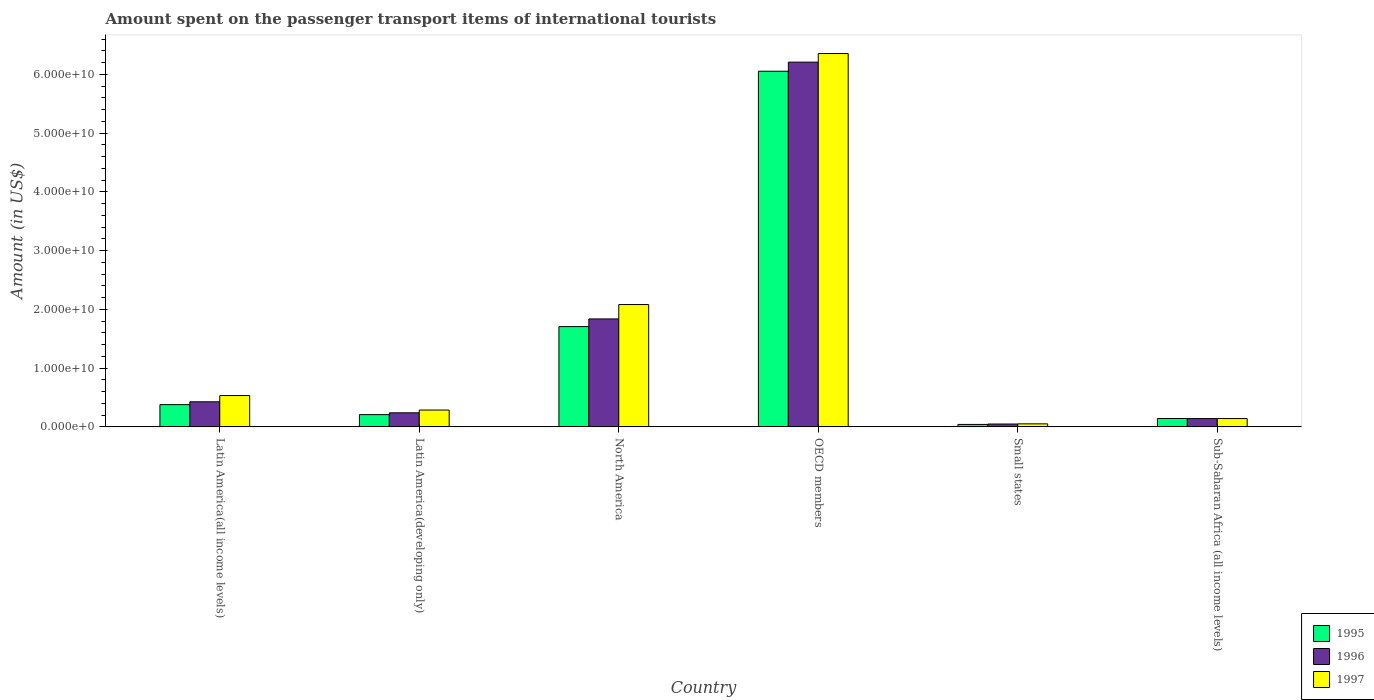How many different coloured bars are there?
Give a very brief answer. 3. How many groups of bars are there?
Keep it short and to the point. 6. Are the number of bars on each tick of the X-axis equal?
Your response must be concise. Yes. How many bars are there on the 3rd tick from the right?
Give a very brief answer. 3. What is the label of the 4th group of bars from the left?
Provide a short and direct response. OECD members. What is the amount spent on the passenger transport items of international tourists in 1997 in Small states?
Make the answer very short. 5.15e+08. Across all countries, what is the maximum amount spent on the passenger transport items of international tourists in 1996?
Your response must be concise. 6.21e+1. Across all countries, what is the minimum amount spent on the passenger transport items of international tourists in 1995?
Keep it short and to the point. 4.15e+08. In which country was the amount spent on the passenger transport items of international tourists in 1995 maximum?
Offer a terse response. OECD members. In which country was the amount spent on the passenger transport items of international tourists in 1995 minimum?
Ensure brevity in your answer.  Small states. What is the total amount spent on the passenger transport items of international tourists in 1995 in the graph?
Offer a terse response. 8.53e+1. What is the difference between the amount spent on the passenger transport items of international tourists in 1995 in Latin America(developing only) and that in Small states?
Your answer should be very brief. 1.67e+09. What is the difference between the amount spent on the passenger transport items of international tourists in 1996 in Latin America(all income levels) and the amount spent on the passenger transport items of international tourists in 1997 in Sub-Saharan Africa (all income levels)?
Your response must be concise. 2.85e+09. What is the average amount spent on the passenger transport items of international tourists in 1995 per country?
Provide a short and direct response. 1.42e+1. What is the difference between the amount spent on the passenger transport items of international tourists of/in 1997 and amount spent on the passenger transport items of international tourists of/in 1995 in Sub-Saharan Africa (all income levels)?
Your response must be concise. -7.08e+06. In how many countries, is the amount spent on the passenger transport items of international tourists in 1996 greater than 64000000000 US$?
Make the answer very short. 0. What is the ratio of the amount spent on the passenger transport items of international tourists in 1996 in North America to that in OECD members?
Your answer should be compact. 0.3. What is the difference between the highest and the second highest amount spent on the passenger transport items of international tourists in 1995?
Your answer should be very brief. -5.68e+1. What is the difference between the highest and the lowest amount spent on the passenger transport items of international tourists in 1997?
Provide a succinct answer. 6.30e+1. Is the sum of the amount spent on the passenger transport items of international tourists in 1997 in Latin America(all income levels) and North America greater than the maximum amount spent on the passenger transport items of international tourists in 1996 across all countries?
Provide a succinct answer. No. Are the values on the major ticks of Y-axis written in scientific E-notation?
Provide a short and direct response. Yes. Does the graph contain any zero values?
Your answer should be compact. No. Does the graph contain grids?
Your answer should be very brief. No. How are the legend labels stacked?
Your response must be concise. Vertical. What is the title of the graph?
Ensure brevity in your answer.  Amount spent on the passenger transport items of international tourists. Does "2000" appear as one of the legend labels in the graph?
Provide a short and direct response. No. What is the label or title of the Y-axis?
Your answer should be very brief. Amount (in US$). What is the Amount (in US$) in 1995 in Latin America(all income levels)?
Make the answer very short. 3.79e+09. What is the Amount (in US$) in 1996 in Latin America(all income levels)?
Your answer should be very brief. 4.27e+09. What is the Amount (in US$) in 1997 in Latin America(all income levels)?
Ensure brevity in your answer.  5.33e+09. What is the Amount (in US$) in 1995 in Latin America(developing only)?
Ensure brevity in your answer.  2.08e+09. What is the Amount (in US$) of 1996 in Latin America(developing only)?
Offer a very short reply. 2.39e+09. What is the Amount (in US$) in 1997 in Latin America(developing only)?
Offer a terse response. 2.87e+09. What is the Amount (in US$) in 1995 in North America?
Offer a very short reply. 1.71e+1. What is the Amount (in US$) of 1996 in North America?
Provide a succinct answer. 1.84e+1. What is the Amount (in US$) in 1997 in North America?
Your answer should be very brief. 2.08e+1. What is the Amount (in US$) of 1995 in OECD members?
Make the answer very short. 6.05e+1. What is the Amount (in US$) of 1996 in OECD members?
Keep it short and to the point. 6.21e+1. What is the Amount (in US$) of 1997 in OECD members?
Offer a very short reply. 6.35e+1. What is the Amount (in US$) of 1995 in Small states?
Offer a very short reply. 4.15e+08. What is the Amount (in US$) of 1996 in Small states?
Your answer should be compact. 4.85e+08. What is the Amount (in US$) in 1997 in Small states?
Give a very brief answer. 5.15e+08. What is the Amount (in US$) in 1995 in Sub-Saharan Africa (all income levels)?
Provide a short and direct response. 1.42e+09. What is the Amount (in US$) in 1996 in Sub-Saharan Africa (all income levels)?
Ensure brevity in your answer.  1.41e+09. What is the Amount (in US$) of 1997 in Sub-Saharan Africa (all income levels)?
Your answer should be compact. 1.42e+09. Across all countries, what is the maximum Amount (in US$) in 1995?
Your response must be concise. 6.05e+1. Across all countries, what is the maximum Amount (in US$) of 1996?
Offer a very short reply. 6.21e+1. Across all countries, what is the maximum Amount (in US$) in 1997?
Offer a terse response. 6.35e+1. Across all countries, what is the minimum Amount (in US$) in 1995?
Your response must be concise. 4.15e+08. Across all countries, what is the minimum Amount (in US$) in 1996?
Make the answer very short. 4.85e+08. Across all countries, what is the minimum Amount (in US$) of 1997?
Give a very brief answer. 5.15e+08. What is the total Amount (in US$) in 1995 in the graph?
Ensure brevity in your answer.  8.53e+1. What is the total Amount (in US$) in 1996 in the graph?
Your response must be concise. 8.90e+1. What is the total Amount (in US$) of 1997 in the graph?
Give a very brief answer. 9.45e+1. What is the difference between the Amount (in US$) of 1995 in Latin America(all income levels) and that in Latin America(developing only)?
Make the answer very short. 1.70e+09. What is the difference between the Amount (in US$) of 1996 in Latin America(all income levels) and that in Latin America(developing only)?
Provide a short and direct response. 1.88e+09. What is the difference between the Amount (in US$) of 1997 in Latin America(all income levels) and that in Latin America(developing only)?
Your response must be concise. 2.47e+09. What is the difference between the Amount (in US$) in 1995 in Latin America(all income levels) and that in North America?
Ensure brevity in your answer.  -1.33e+1. What is the difference between the Amount (in US$) of 1996 in Latin America(all income levels) and that in North America?
Keep it short and to the point. -1.41e+1. What is the difference between the Amount (in US$) in 1997 in Latin America(all income levels) and that in North America?
Provide a short and direct response. -1.55e+1. What is the difference between the Amount (in US$) in 1995 in Latin America(all income levels) and that in OECD members?
Ensure brevity in your answer.  -5.68e+1. What is the difference between the Amount (in US$) in 1996 in Latin America(all income levels) and that in OECD members?
Ensure brevity in your answer.  -5.78e+1. What is the difference between the Amount (in US$) of 1997 in Latin America(all income levels) and that in OECD members?
Make the answer very short. -5.82e+1. What is the difference between the Amount (in US$) of 1995 in Latin America(all income levels) and that in Small states?
Keep it short and to the point. 3.37e+09. What is the difference between the Amount (in US$) of 1996 in Latin America(all income levels) and that in Small states?
Provide a short and direct response. 3.78e+09. What is the difference between the Amount (in US$) of 1997 in Latin America(all income levels) and that in Small states?
Provide a succinct answer. 4.82e+09. What is the difference between the Amount (in US$) in 1995 in Latin America(all income levels) and that in Sub-Saharan Africa (all income levels)?
Ensure brevity in your answer.  2.36e+09. What is the difference between the Amount (in US$) of 1996 in Latin America(all income levels) and that in Sub-Saharan Africa (all income levels)?
Your answer should be very brief. 2.86e+09. What is the difference between the Amount (in US$) of 1997 in Latin America(all income levels) and that in Sub-Saharan Africa (all income levels)?
Keep it short and to the point. 3.92e+09. What is the difference between the Amount (in US$) of 1995 in Latin America(developing only) and that in North America?
Provide a succinct answer. -1.50e+1. What is the difference between the Amount (in US$) of 1996 in Latin America(developing only) and that in North America?
Offer a terse response. -1.60e+1. What is the difference between the Amount (in US$) of 1997 in Latin America(developing only) and that in North America?
Your answer should be compact. -1.80e+1. What is the difference between the Amount (in US$) in 1995 in Latin America(developing only) and that in OECD members?
Make the answer very short. -5.85e+1. What is the difference between the Amount (in US$) in 1996 in Latin America(developing only) and that in OECD members?
Offer a very short reply. -5.97e+1. What is the difference between the Amount (in US$) of 1997 in Latin America(developing only) and that in OECD members?
Keep it short and to the point. -6.07e+1. What is the difference between the Amount (in US$) in 1995 in Latin America(developing only) and that in Small states?
Give a very brief answer. 1.67e+09. What is the difference between the Amount (in US$) in 1996 in Latin America(developing only) and that in Small states?
Your response must be concise. 1.91e+09. What is the difference between the Amount (in US$) of 1997 in Latin America(developing only) and that in Small states?
Provide a succinct answer. 2.35e+09. What is the difference between the Amount (in US$) in 1995 in Latin America(developing only) and that in Sub-Saharan Africa (all income levels)?
Ensure brevity in your answer.  6.61e+08. What is the difference between the Amount (in US$) of 1996 in Latin America(developing only) and that in Sub-Saharan Africa (all income levels)?
Your response must be concise. 9.78e+08. What is the difference between the Amount (in US$) of 1997 in Latin America(developing only) and that in Sub-Saharan Africa (all income levels)?
Provide a succinct answer. 1.45e+09. What is the difference between the Amount (in US$) in 1995 in North America and that in OECD members?
Your answer should be compact. -4.35e+1. What is the difference between the Amount (in US$) of 1996 in North America and that in OECD members?
Ensure brevity in your answer.  -4.37e+1. What is the difference between the Amount (in US$) in 1997 in North America and that in OECD members?
Give a very brief answer. -4.27e+1. What is the difference between the Amount (in US$) of 1995 in North America and that in Small states?
Offer a very short reply. 1.67e+1. What is the difference between the Amount (in US$) in 1996 in North America and that in Small states?
Make the answer very short. 1.79e+1. What is the difference between the Amount (in US$) of 1997 in North America and that in Small states?
Your response must be concise. 2.03e+1. What is the difference between the Amount (in US$) in 1995 in North America and that in Sub-Saharan Africa (all income levels)?
Ensure brevity in your answer.  1.56e+1. What is the difference between the Amount (in US$) in 1996 in North America and that in Sub-Saharan Africa (all income levels)?
Your answer should be very brief. 1.70e+1. What is the difference between the Amount (in US$) of 1997 in North America and that in Sub-Saharan Africa (all income levels)?
Provide a short and direct response. 1.94e+1. What is the difference between the Amount (in US$) of 1995 in OECD members and that in Small states?
Make the answer very short. 6.01e+1. What is the difference between the Amount (in US$) in 1996 in OECD members and that in Small states?
Provide a succinct answer. 6.16e+1. What is the difference between the Amount (in US$) in 1997 in OECD members and that in Small states?
Make the answer very short. 6.30e+1. What is the difference between the Amount (in US$) of 1995 in OECD members and that in Sub-Saharan Africa (all income levels)?
Offer a very short reply. 5.91e+1. What is the difference between the Amount (in US$) of 1996 in OECD members and that in Sub-Saharan Africa (all income levels)?
Your answer should be very brief. 6.07e+1. What is the difference between the Amount (in US$) in 1997 in OECD members and that in Sub-Saharan Africa (all income levels)?
Offer a very short reply. 6.21e+1. What is the difference between the Amount (in US$) of 1995 in Small states and that in Sub-Saharan Africa (all income levels)?
Ensure brevity in your answer.  -1.01e+09. What is the difference between the Amount (in US$) of 1996 in Small states and that in Sub-Saharan Africa (all income levels)?
Ensure brevity in your answer.  -9.28e+08. What is the difference between the Amount (in US$) of 1997 in Small states and that in Sub-Saharan Africa (all income levels)?
Offer a very short reply. -9.01e+08. What is the difference between the Amount (in US$) of 1995 in Latin America(all income levels) and the Amount (in US$) of 1996 in Latin America(developing only)?
Your response must be concise. 1.39e+09. What is the difference between the Amount (in US$) in 1995 in Latin America(all income levels) and the Amount (in US$) in 1997 in Latin America(developing only)?
Ensure brevity in your answer.  9.19e+08. What is the difference between the Amount (in US$) in 1996 in Latin America(all income levels) and the Amount (in US$) in 1997 in Latin America(developing only)?
Make the answer very short. 1.40e+09. What is the difference between the Amount (in US$) of 1995 in Latin America(all income levels) and the Amount (in US$) of 1996 in North America?
Offer a very short reply. -1.46e+1. What is the difference between the Amount (in US$) in 1995 in Latin America(all income levels) and the Amount (in US$) in 1997 in North America?
Your answer should be compact. -1.70e+1. What is the difference between the Amount (in US$) of 1996 in Latin America(all income levels) and the Amount (in US$) of 1997 in North America?
Your response must be concise. -1.66e+1. What is the difference between the Amount (in US$) in 1995 in Latin America(all income levels) and the Amount (in US$) in 1996 in OECD members?
Your answer should be compact. -5.83e+1. What is the difference between the Amount (in US$) of 1995 in Latin America(all income levels) and the Amount (in US$) of 1997 in OECD members?
Give a very brief answer. -5.98e+1. What is the difference between the Amount (in US$) in 1996 in Latin America(all income levels) and the Amount (in US$) in 1997 in OECD members?
Make the answer very short. -5.93e+1. What is the difference between the Amount (in US$) of 1995 in Latin America(all income levels) and the Amount (in US$) of 1996 in Small states?
Your response must be concise. 3.30e+09. What is the difference between the Amount (in US$) of 1995 in Latin America(all income levels) and the Amount (in US$) of 1997 in Small states?
Offer a very short reply. 3.27e+09. What is the difference between the Amount (in US$) in 1996 in Latin America(all income levels) and the Amount (in US$) in 1997 in Small states?
Give a very brief answer. 3.75e+09. What is the difference between the Amount (in US$) of 1995 in Latin America(all income levels) and the Amount (in US$) of 1996 in Sub-Saharan Africa (all income levels)?
Offer a terse response. 2.37e+09. What is the difference between the Amount (in US$) in 1995 in Latin America(all income levels) and the Amount (in US$) in 1997 in Sub-Saharan Africa (all income levels)?
Keep it short and to the point. 2.37e+09. What is the difference between the Amount (in US$) of 1996 in Latin America(all income levels) and the Amount (in US$) of 1997 in Sub-Saharan Africa (all income levels)?
Your response must be concise. 2.85e+09. What is the difference between the Amount (in US$) of 1995 in Latin America(developing only) and the Amount (in US$) of 1996 in North America?
Keep it short and to the point. -1.63e+1. What is the difference between the Amount (in US$) in 1995 in Latin America(developing only) and the Amount (in US$) in 1997 in North America?
Ensure brevity in your answer.  -1.87e+1. What is the difference between the Amount (in US$) in 1996 in Latin America(developing only) and the Amount (in US$) in 1997 in North America?
Offer a very short reply. -1.84e+1. What is the difference between the Amount (in US$) of 1995 in Latin America(developing only) and the Amount (in US$) of 1996 in OECD members?
Your answer should be compact. -6.00e+1. What is the difference between the Amount (in US$) of 1995 in Latin America(developing only) and the Amount (in US$) of 1997 in OECD members?
Offer a terse response. -6.15e+1. What is the difference between the Amount (in US$) in 1996 in Latin America(developing only) and the Amount (in US$) in 1997 in OECD members?
Ensure brevity in your answer.  -6.12e+1. What is the difference between the Amount (in US$) of 1995 in Latin America(developing only) and the Amount (in US$) of 1996 in Small states?
Your answer should be very brief. 1.60e+09. What is the difference between the Amount (in US$) of 1995 in Latin America(developing only) and the Amount (in US$) of 1997 in Small states?
Your answer should be compact. 1.57e+09. What is the difference between the Amount (in US$) in 1996 in Latin America(developing only) and the Amount (in US$) in 1997 in Small states?
Provide a succinct answer. 1.88e+09. What is the difference between the Amount (in US$) of 1995 in Latin America(developing only) and the Amount (in US$) of 1996 in Sub-Saharan Africa (all income levels)?
Your response must be concise. 6.71e+08. What is the difference between the Amount (in US$) of 1995 in Latin America(developing only) and the Amount (in US$) of 1997 in Sub-Saharan Africa (all income levels)?
Give a very brief answer. 6.68e+08. What is the difference between the Amount (in US$) of 1996 in Latin America(developing only) and the Amount (in US$) of 1997 in Sub-Saharan Africa (all income levels)?
Ensure brevity in your answer.  9.75e+08. What is the difference between the Amount (in US$) of 1995 in North America and the Amount (in US$) of 1996 in OECD members?
Keep it short and to the point. -4.50e+1. What is the difference between the Amount (in US$) in 1995 in North America and the Amount (in US$) in 1997 in OECD members?
Make the answer very short. -4.65e+1. What is the difference between the Amount (in US$) in 1996 in North America and the Amount (in US$) in 1997 in OECD members?
Your answer should be very brief. -4.52e+1. What is the difference between the Amount (in US$) of 1995 in North America and the Amount (in US$) of 1996 in Small states?
Your answer should be very brief. 1.66e+1. What is the difference between the Amount (in US$) of 1995 in North America and the Amount (in US$) of 1997 in Small states?
Offer a very short reply. 1.66e+1. What is the difference between the Amount (in US$) in 1996 in North America and the Amount (in US$) in 1997 in Small states?
Give a very brief answer. 1.79e+1. What is the difference between the Amount (in US$) of 1995 in North America and the Amount (in US$) of 1996 in Sub-Saharan Africa (all income levels)?
Make the answer very short. 1.57e+1. What is the difference between the Amount (in US$) of 1995 in North America and the Amount (in US$) of 1997 in Sub-Saharan Africa (all income levels)?
Your answer should be compact. 1.57e+1. What is the difference between the Amount (in US$) in 1996 in North America and the Amount (in US$) in 1997 in Sub-Saharan Africa (all income levels)?
Your answer should be compact. 1.70e+1. What is the difference between the Amount (in US$) in 1995 in OECD members and the Amount (in US$) in 1996 in Small states?
Keep it short and to the point. 6.01e+1. What is the difference between the Amount (in US$) of 1995 in OECD members and the Amount (in US$) of 1997 in Small states?
Your answer should be very brief. 6.00e+1. What is the difference between the Amount (in US$) in 1996 in OECD members and the Amount (in US$) in 1997 in Small states?
Offer a terse response. 6.16e+1. What is the difference between the Amount (in US$) in 1995 in OECD members and the Amount (in US$) in 1996 in Sub-Saharan Africa (all income levels)?
Your answer should be very brief. 5.91e+1. What is the difference between the Amount (in US$) of 1995 in OECD members and the Amount (in US$) of 1997 in Sub-Saharan Africa (all income levels)?
Make the answer very short. 5.91e+1. What is the difference between the Amount (in US$) of 1996 in OECD members and the Amount (in US$) of 1997 in Sub-Saharan Africa (all income levels)?
Offer a terse response. 6.07e+1. What is the difference between the Amount (in US$) of 1995 in Small states and the Amount (in US$) of 1996 in Sub-Saharan Africa (all income levels)?
Ensure brevity in your answer.  -9.98e+08. What is the difference between the Amount (in US$) of 1995 in Small states and the Amount (in US$) of 1997 in Sub-Saharan Africa (all income levels)?
Offer a terse response. -1.00e+09. What is the difference between the Amount (in US$) in 1996 in Small states and the Amount (in US$) in 1997 in Sub-Saharan Africa (all income levels)?
Provide a short and direct response. -9.31e+08. What is the average Amount (in US$) of 1995 per country?
Your answer should be very brief. 1.42e+1. What is the average Amount (in US$) of 1996 per country?
Your answer should be compact. 1.48e+1. What is the average Amount (in US$) in 1997 per country?
Your answer should be compact. 1.57e+1. What is the difference between the Amount (in US$) of 1995 and Amount (in US$) of 1996 in Latin America(all income levels)?
Offer a terse response. -4.84e+08. What is the difference between the Amount (in US$) in 1995 and Amount (in US$) in 1997 in Latin America(all income levels)?
Offer a very short reply. -1.55e+09. What is the difference between the Amount (in US$) of 1996 and Amount (in US$) of 1997 in Latin America(all income levels)?
Provide a short and direct response. -1.06e+09. What is the difference between the Amount (in US$) in 1995 and Amount (in US$) in 1996 in Latin America(developing only)?
Your response must be concise. -3.07e+08. What is the difference between the Amount (in US$) of 1995 and Amount (in US$) of 1997 in Latin America(developing only)?
Make the answer very short. -7.82e+08. What is the difference between the Amount (in US$) in 1996 and Amount (in US$) in 1997 in Latin America(developing only)?
Give a very brief answer. -4.75e+08. What is the difference between the Amount (in US$) in 1995 and Amount (in US$) in 1996 in North America?
Ensure brevity in your answer.  -1.31e+09. What is the difference between the Amount (in US$) of 1995 and Amount (in US$) of 1997 in North America?
Provide a succinct answer. -3.75e+09. What is the difference between the Amount (in US$) of 1996 and Amount (in US$) of 1997 in North America?
Make the answer very short. -2.45e+09. What is the difference between the Amount (in US$) in 1995 and Amount (in US$) in 1996 in OECD members?
Your response must be concise. -1.55e+09. What is the difference between the Amount (in US$) in 1995 and Amount (in US$) in 1997 in OECD members?
Keep it short and to the point. -3.01e+09. What is the difference between the Amount (in US$) of 1996 and Amount (in US$) of 1997 in OECD members?
Keep it short and to the point. -1.46e+09. What is the difference between the Amount (in US$) of 1995 and Amount (in US$) of 1996 in Small states?
Offer a terse response. -6.97e+07. What is the difference between the Amount (in US$) of 1995 and Amount (in US$) of 1997 in Small states?
Your response must be concise. -9.94e+07. What is the difference between the Amount (in US$) in 1996 and Amount (in US$) in 1997 in Small states?
Your answer should be very brief. -2.97e+07. What is the difference between the Amount (in US$) in 1995 and Amount (in US$) in 1996 in Sub-Saharan Africa (all income levels)?
Make the answer very short. 9.58e+06. What is the difference between the Amount (in US$) in 1995 and Amount (in US$) in 1997 in Sub-Saharan Africa (all income levels)?
Your response must be concise. 7.08e+06. What is the difference between the Amount (in US$) in 1996 and Amount (in US$) in 1997 in Sub-Saharan Africa (all income levels)?
Provide a succinct answer. -2.51e+06. What is the ratio of the Amount (in US$) of 1995 in Latin America(all income levels) to that in Latin America(developing only)?
Your answer should be very brief. 1.82. What is the ratio of the Amount (in US$) in 1996 in Latin America(all income levels) to that in Latin America(developing only)?
Offer a very short reply. 1.79. What is the ratio of the Amount (in US$) in 1997 in Latin America(all income levels) to that in Latin America(developing only)?
Offer a very short reply. 1.86. What is the ratio of the Amount (in US$) in 1995 in Latin America(all income levels) to that in North America?
Provide a succinct answer. 0.22. What is the ratio of the Amount (in US$) of 1996 in Latin America(all income levels) to that in North America?
Offer a very short reply. 0.23. What is the ratio of the Amount (in US$) of 1997 in Latin America(all income levels) to that in North America?
Offer a very short reply. 0.26. What is the ratio of the Amount (in US$) in 1995 in Latin America(all income levels) to that in OECD members?
Ensure brevity in your answer.  0.06. What is the ratio of the Amount (in US$) of 1996 in Latin America(all income levels) to that in OECD members?
Offer a very short reply. 0.07. What is the ratio of the Amount (in US$) in 1997 in Latin America(all income levels) to that in OECD members?
Give a very brief answer. 0.08. What is the ratio of the Amount (in US$) of 1995 in Latin America(all income levels) to that in Small states?
Keep it short and to the point. 9.11. What is the ratio of the Amount (in US$) in 1996 in Latin America(all income levels) to that in Small states?
Make the answer very short. 8.8. What is the ratio of the Amount (in US$) of 1997 in Latin America(all income levels) to that in Small states?
Offer a very short reply. 10.36. What is the ratio of the Amount (in US$) in 1995 in Latin America(all income levels) to that in Sub-Saharan Africa (all income levels)?
Offer a very short reply. 2.66. What is the ratio of the Amount (in US$) in 1996 in Latin America(all income levels) to that in Sub-Saharan Africa (all income levels)?
Keep it short and to the point. 3.02. What is the ratio of the Amount (in US$) of 1997 in Latin America(all income levels) to that in Sub-Saharan Africa (all income levels)?
Provide a short and direct response. 3.77. What is the ratio of the Amount (in US$) of 1995 in Latin America(developing only) to that in North America?
Offer a terse response. 0.12. What is the ratio of the Amount (in US$) of 1996 in Latin America(developing only) to that in North America?
Your answer should be compact. 0.13. What is the ratio of the Amount (in US$) in 1997 in Latin America(developing only) to that in North America?
Your answer should be very brief. 0.14. What is the ratio of the Amount (in US$) in 1995 in Latin America(developing only) to that in OECD members?
Provide a succinct answer. 0.03. What is the ratio of the Amount (in US$) in 1996 in Latin America(developing only) to that in OECD members?
Keep it short and to the point. 0.04. What is the ratio of the Amount (in US$) in 1997 in Latin America(developing only) to that in OECD members?
Offer a terse response. 0.05. What is the ratio of the Amount (in US$) of 1995 in Latin America(developing only) to that in Small states?
Offer a very short reply. 5.02. What is the ratio of the Amount (in US$) of 1996 in Latin America(developing only) to that in Small states?
Offer a very short reply. 4.93. What is the ratio of the Amount (in US$) in 1997 in Latin America(developing only) to that in Small states?
Offer a terse response. 5.57. What is the ratio of the Amount (in US$) of 1995 in Latin America(developing only) to that in Sub-Saharan Africa (all income levels)?
Give a very brief answer. 1.46. What is the ratio of the Amount (in US$) of 1996 in Latin America(developing only) to that in Sub-Saharan Africa (all income levels)?
Your answer should be very brief. 1.69. What is the ratio of the Amount (in US$) in 1997 in Latin America(developing only) to that in Sub-Saharan Africa (all income levels)?
Offer a very short reply. 2.02. What is the ratio of the Amount (in US$) of 1995 in North America to that in OECD members?
Your answer should be very brief. 0.28. What is the ratio of the Amount (in US$) of 1996 in North America to that in OECD members?
Ensure brevity in your answer.  0.3. What is the ratio of the Amount (in US$) in 1997 in North America to that in OECD members?
Keep it short and to the point. 0.33. What is the ratio of the Amount (in US$) in 1995 in North America to that in Small states?
Your answer should be very brief. 41.09. What is the ratio of the Amount (in US$) in 1996 in North America to that in Small states?
Give a very brief answer. 37.87. What is the ratio of the Amount (in US$) in 1997 in North America to that in Small states?
Keep it short and to the point. 40.44. What is the ratio of the Amount (in US$) in 1995 in North America to that in Sub-Saharan Africa (all income levels)?
Offer a very short reply. 11.99. What is the ratio of the Amount (in US$) of 1996 in North America to that in Sub-Saharan Africa (all income levels)?
Your answer should be very brief. 13. What is the ratio of the Amount (in US$) of 1997 in North America to that in Sub-Saharan Africa (all income levels)?
Your answer should be very brief. 14.7. What is the ratio of the Amount (in US$) of 1995 in OECD members to that in Small states?
Keep it short and to the point. 145.72. What is the ratio of the Amount (in US$) in 1996 in OECD members to that in Small states?
Ensure brevity in your answer.  127.96. What is the ratio of the Amount (in US$) of 1997 in OECD members to that in Small states?
Ensure brevity in your answer.  123.42. What is the ratio of the Amount (in US$) of 1995 in OECD members to that in Sub-Saharan Africa (all income levels)?
Give a very brief answer. 42.54. What is the ratio of the Amount (in US$) in 1996 in OECD members to that in Sub-Saharan Africa (all income levels)?
Provide a succinct answer. 43.92. What is the ratio of the Amount (in US$) in 1997 in OECD members to that in Sub-Saharan Africa (all income levels)?
Keep it short and to the point. 44.87. What is the ratio of the Amount (in US$) in 1995 in Small states to that in Sub-Saharan Africa (all income levels)?
Provide a short and direct response. 0.29. What is the ratio of the Amount (in US$) in 1996 in Small states to that in Sub-Saharan Africa (all income levels)?
Provide a short and direct response. 0.34. What is the ratio of the Amount (in US$) in 1997 in Small states to that in Sub-Saharan Africa (all income levels)?
Give a very brief answer. 0.36. What is the difference between the highest and the second highest Amount (in US$) in 1995?
Keep it short and to the point. 4.35e+1. What is the difference between the highest and the second highest Amount (in US$) of 1996?
Your answer should be compact. 4.37e+1. What is the difference between the highest and the second highest Amount (in US$) in 1997?
Give a very brief answer. 4.27e+1. What is the difference between the highest and the lowest Amount (in US$) in 1995?
Make the answer very short. 6.01e+1. What is the difference between the highest and the lowest Amount (in US$) of 1996?
Your response must be concise. 6.16e+1. What is the difference between the highest and the lowest Amount (in US$) of 1997?
Your response must be concise. 6.30e+1. 